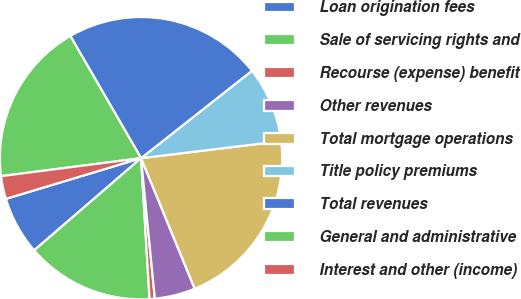Convert chart. <chart><loc_0><loc_0><loc_500><loc_500><pie_chart><fcel>Loan origination fees<fcel>Sale of servicing rights and<fcel>Recourse (expense) benefit<fcel>Other revenues<fcel>Total mortgage operations<fcel>Title policy premiums<fcel>Total revenues<fcel>General and administrative<fcel>Interest and other (income)<nl><fcel>6.67%<fcel>14.63%<fcel>0.6%<fcel>4.65%<fcel>20.71%<fcel>8.7%<fcel>22.73%<fcel>18.68%<fcel>2.62%<nl></chart> 